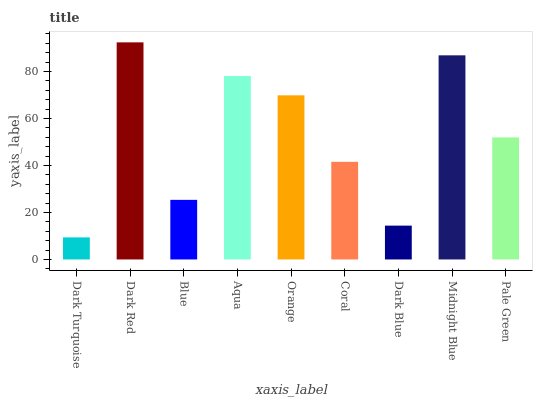Is Dark Turquoise the minimum?
Answer yes or no. Yes. Is Dark Red the maximum?
Answer yes or no. Yes. Is Blue the minimum?
Answer yes or no. No. Is Blue the maximum?
Answer yes or no. No. Is Dark Red greater than Blue?
Answer yes or no. Yes. Is Blue less than Dark Red?
Answer yes or no. Yes. Is Blue greater than Dark Red?
Answer yes or no. No. Is Dark Red less than Blue?
Answer yes or no. No. Is Pale Green the high median?
Answer yes or no. Yes. Is Pale Green the low median?
Answer yes or no. Yes. Is Coral the high median?
Answer yes or no. No. Is Dark Turquoise the low median?
Answer yes or no. No. 